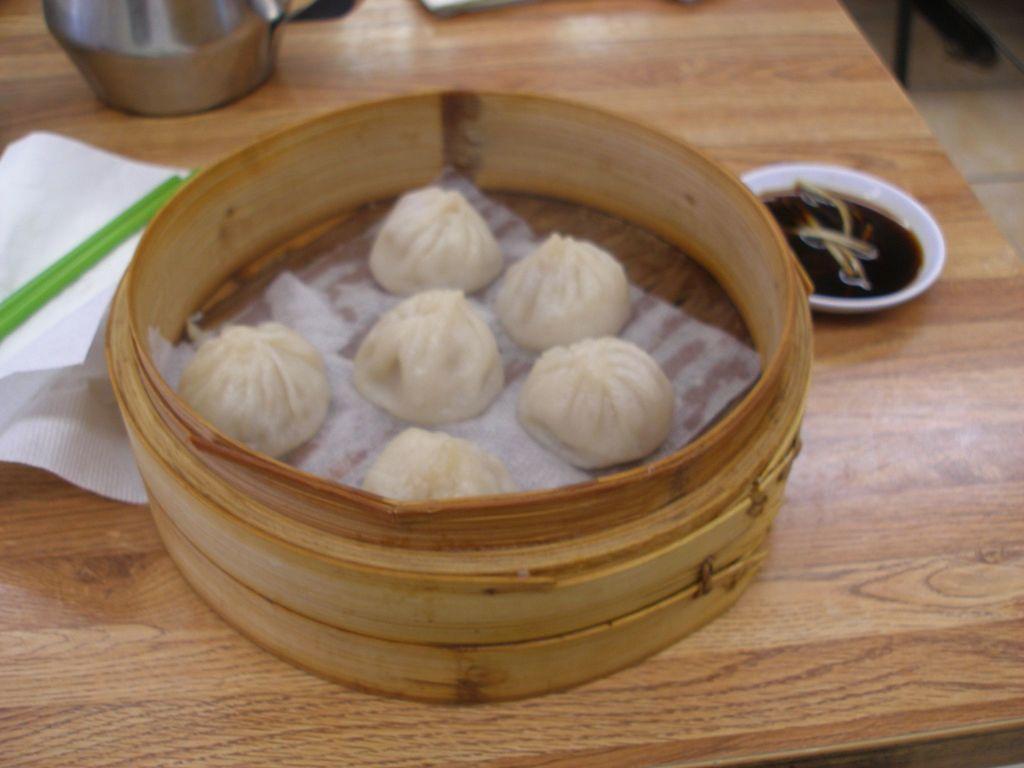How would you summarize this image in a sentence or two? In this picture there are few eatables placed in a wooden object which is on the table and there are few other objects on it. 